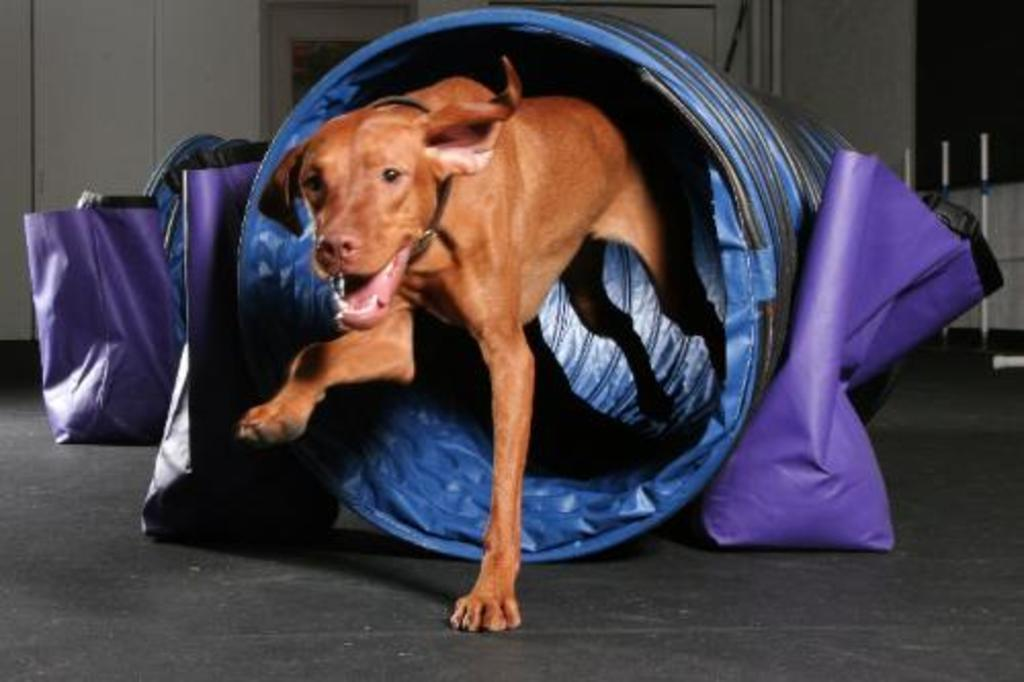What animal is in the blue object in the image? There is a dog in a blue object in the image. What can be seen on the floor in the image? There are bags and other objects on the floor in the image. What is visible in the background of the image? There is a wall visible in the background of the image. How does the dog increase its height in the image? The dog does not increase its height in the image; it remains at its normal height. 